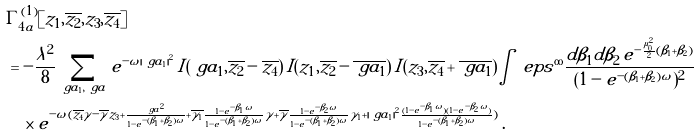<formula> <loc_0><loc_0><loc_500><loc_500>& \Gamma ^ { ( 1 ) } _ { 4 a } [ z _ { 1 } , \overline { z _ { 2 } } , z _ { 3 } , \overline { z _ { 4 } } ] \\ & = - \frac { \lambda ^ { 2 } } { 8 } \sum _ { \ g a _ { 1 } , \ g a } e ^ { - \omega | \ g a _ { 1 } | ^ { 2 } } \, I ( \ g a _ { 1 } , \overline { z _ { 2 } } - \overline { z _ { 4 } } ) \, I ( z _ { 1 } , \overline { z _ { 2 } } - \overline { \ g a _ { 1 } } ) \, I ( z _ { 3 } , \overline { z _ { 4 } } + \overline { \ g a _ { 1 } } ) \int _ { \ } e p s ^ { \infty } \frac { d \beta _ { 1 } d \beta _ { 2 } \, e ^ { - \frac { \mu _ { 0 } ^ { 2 } } { 2 } ( \beta _ { 1 } + \beta _ { 2 } ) } } { ( 1 - e ^ { - ( \beta _ { 1 } + \beta _ { 2 } ) \omega } ) ^ { 2 } } \\ & \quad \times e ^ { - \omega ( \overline { z _ { 4 } } \gamma - \overline { \gamma } z _ { 3 } + \frac { | \ g a | ^ { 2 } } { 1 - e ^ { - ( \beta _ { 1 } + \beta _ { 2 } ) \omega } } + \overline { \gamma _ { 1 } } \frac { 1 - e ^ { - \beta _ { 1 } \omega } } { 1 - e ^ { - ( \beta _ { 1 } + \beta _ { 2 } ) \omega } } \gamma + \overline { \gamma } \frac { 1 - e ^ { - \beta _ { 2 } \omega } } { 1 - e ^ { - ( \beta _ { 1 } + \beta _ { 2 } ) \omega } } \gamma _ { 1 } + | \ g a _ { 1 } | ^ { 2 } \frac { ( 1 - e ^ { - \beta _ { 1 } \omega } ) ( 1 - e ^ { - \beta _ { 2 } \omega } ) } { 1 - e ^ { - ( \beta _ { 1 } + \beta _ { 2 } ) \omega } } ) } \, .</formula> 